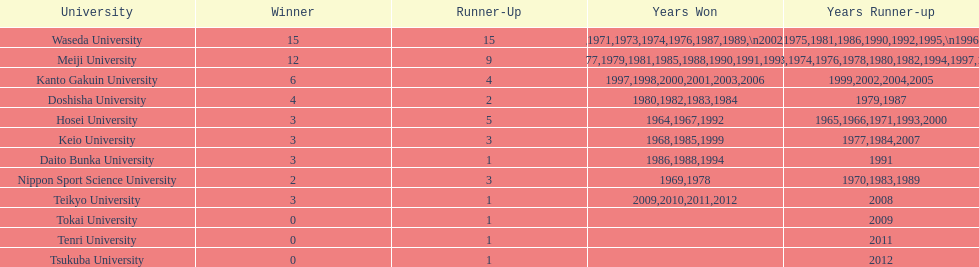Who was the victor of the most recent championship mentioned on this chart? Teikyo University. 